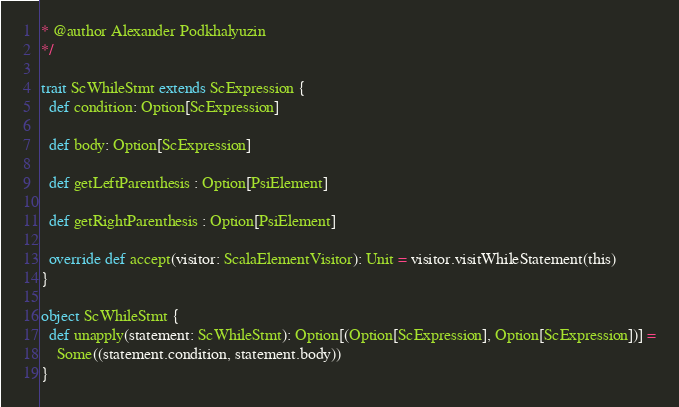<code> <loc_0><loc_0><loc_500><loc_500><_Scala_>* @author Alexander Podkhalyuzin
*/

trait ScWhileStmt extends ScExpression {
  def condition: Option[ScExpression]

  def body: Option[ScExpression]

  def getLeftParenthesis : Option[PsiElement]

  def getRightParenthesis : Option[PsiElement]

  override def accept(visitor: ScalaElementVisitor): Unit = visitor.visitWhileStatement(this)
}

object ScWhileStmt {
  def unapply(statement: ScWhileStmt): Option[(Option[ScExpression], Option[ScExpression])] =
    Some((statement.condition, statement.body))
}</code> 